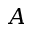Convert formula to latex. <formula><loc_0><loc_0><loc_500><loc_500>A</formula> 